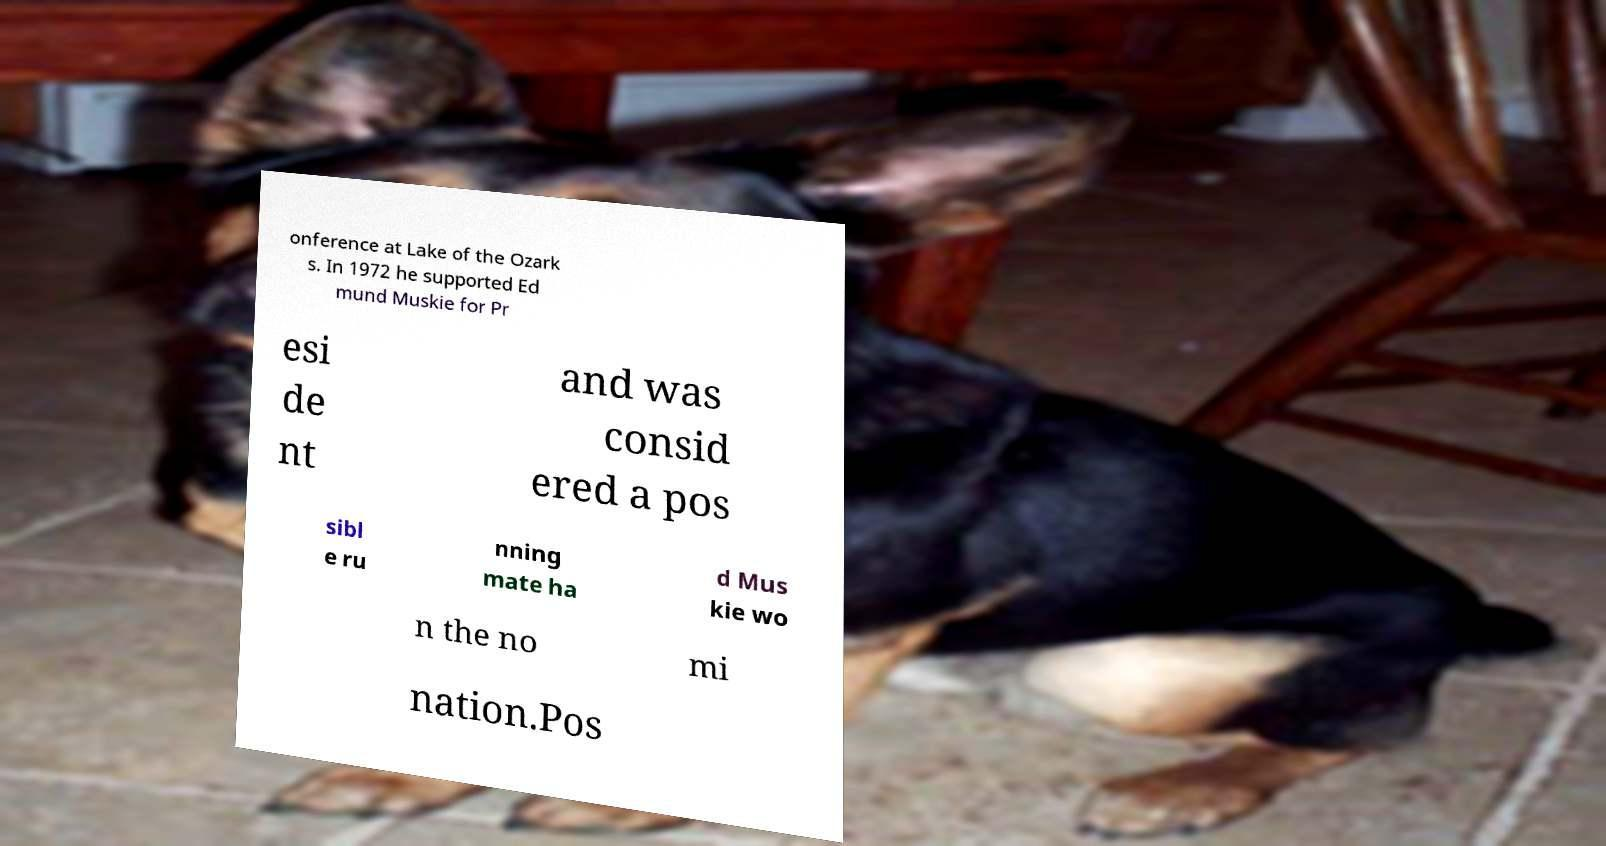Could you assist in decoding the text presented in this image and type it out clearly? onference at Lake of the Ozark s. In 1972 he supported Ed mund Muskie for Pr esi de nt and was consid ered a pos sibl e ru nning mate ha d Mus kie wo n the no mi nation.Pos 